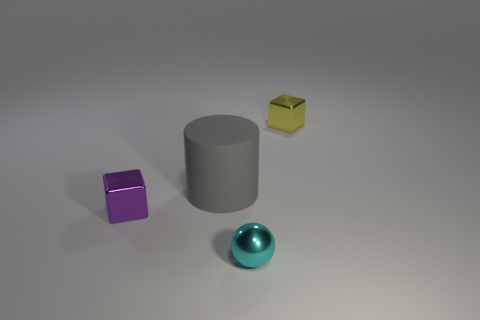There is a metallic thing behind the purple metallic object; is its shape the same as the tiny object that is left of the sphere?
Offer a very short reply. Yes. There is a thing that is to the left of the big gray rubber cylinder; what size is it?
Provide a succinct answer. Small. What size is the cube in front of the metallic thing that is behind the small purple metal object?
Give a very brief answer. Small. Is the number of small yellow things greater than the number of green matte cubes?
Your answer should be very brief. Yes. Are there more small yellow metal things that are behind the purple object than small yellow metal things in front of the large object?
Your answer should be compact. Yes. What size is the object that is both right of the tiny purple object and to the left of the tiny cyan sphere?
Offer a terse response. Large. How many cyan spheres have the same size as the cyan object?
Your response must be concise. 0. There is a shiny thing that is behind the purple thing; does it have the same shape as the matte thing?
Offer a terse response. No. Is the number of shiny cubes in front of the large gray matte object less than the number of small gray matte cubes?
Provide a succinct answer. No. Does the small purple metallic object have the same shape as the tiny metal thing on the right side of the tiny sphere?
Your response must be concise. Yes. 